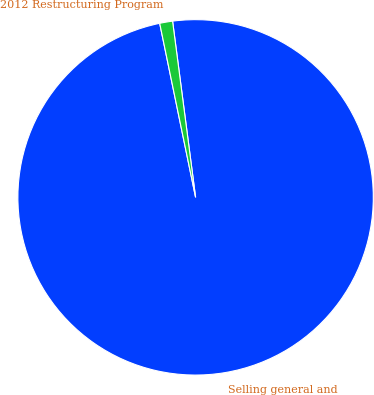<chart> <loc_0><loc_0><loc_500><loc_500><pie_chart><fcel>Selling general and<fcel>2012 Restructuring Program<nl><fcel>98.83%<fcel>1.17%<nl></chart> 